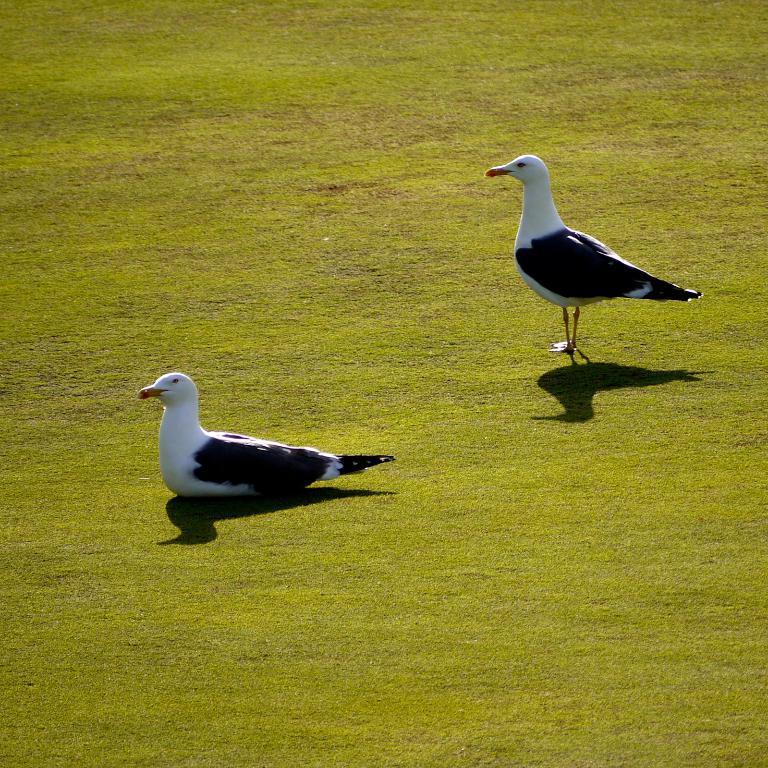In one or two sentences, can you explain what this image depicts? In this image we can see birds on the grass. 